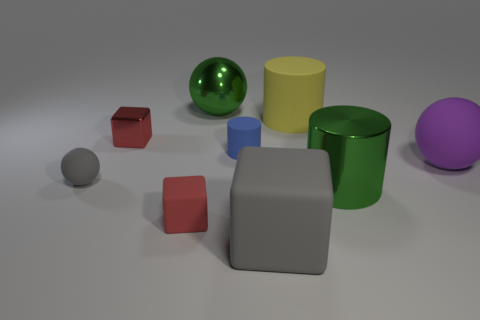Subtract all matte spheres. How many spheres are left? 1 Subtract all cubes. How many objects are left? 6 Add 8 tiny gray spheres. How many tiny gray spheres exist? 9 Subtract 1 yellow cylinders. How many objects are left? 8 Subtract all small cyan metal balls. Subtract all tiny metal things. How many objects are left? 8 Add 5 large green shiny things. How many large green shiny things are left? 7 